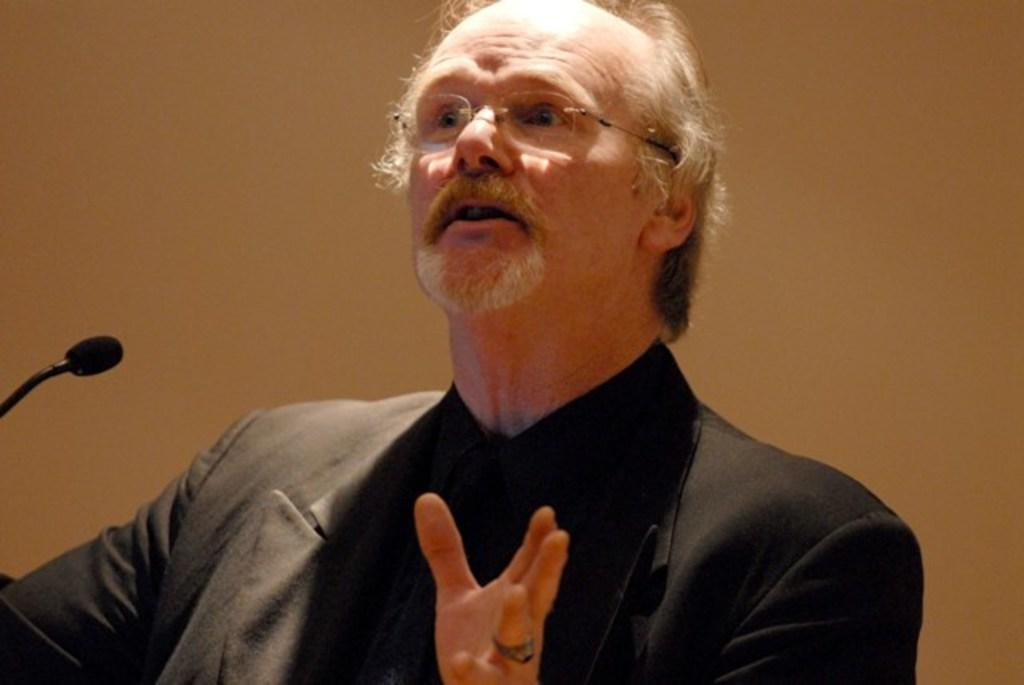Who is the main subject in the image? There is a man in the center of the image. What is the man wearing? The man is wearing a black suit. What object is in front of the man? There is a microphone (mic) in front of the man. What type of animal is the man treating with his medical expertise in the image? There is no animal present in the image, and the man is not depicted as a doctor. 